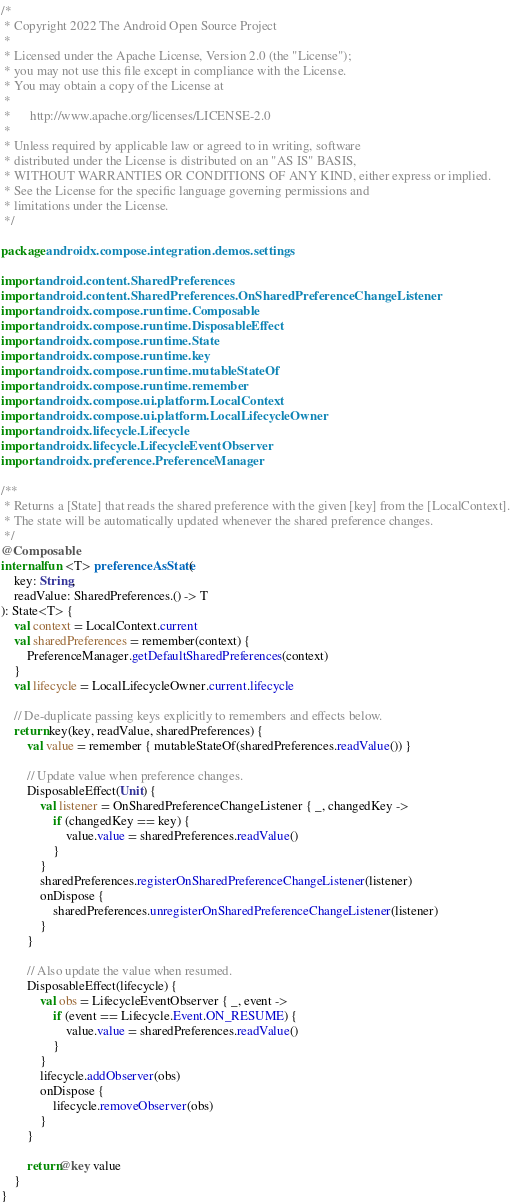<code> <loc_0><loc_0><loc_500><loc_500><_Kotlin_>/*
 * Copyright 2022 The Android Open Source Project
 *
 * Licensed under the Apache License, Version 2.0 (the "License");
 * you may not use this file except in compliance with the License.
 * You may obtain a copy of the License at
 *
 *      http://www.apache.org/licenses/LICENSE-2.0
 *
 * Unless required by applicable law or agreed to in writing, software
 * distributed under the License is distributed on an "AS IS" BASIS,
 * WITHOUT WARRANTIES OR CONDITIONS OF ANY KIND, either express or implied.
 * See the License for the specific language governing permissions and
 * limitations under the License.
 */

package androidx.compose.integration.demos.settings

import android.content.SharedPreferences
import android.content.SharedPreferences.OnSharedPreferenceChangeListener
import androidx.compose.runtime.Composable
import androidx.compose.runtime.DisposableEffect
import androidx.compose.runtime.State
import androidx.compose.runtime.key
import androidx.compose.runtime.mutableStateOf
import androidx.compose.runtime.remember
import androidx.compose.ui.platform.LocalContext
import androidx.compose.ui.platform.LocalLifecycleOwner
import androidx.lifecycle.Lifecycle
import androidx.lifecycle.LifecycleEventObserver
import androidx.preference.PreferenceManager

/**
 * Returns a [State] that reads the shared preference with the given [key] from the [LocalContext].
 * The state will be automatically updated whenever the shared preference changes.
 */
@Composable
internal fun <T> preferenceAsState(
    key: String,
    readValue: SharedPreferences.() -> T
): State<T> {
    val context = LocalContext.current
    val sharedPreferences = remember(context) {
        PreferenceManager.getDefaultSharedPreferences(context)
    }
    val lifecycle = LocalLifecycleOwner.current.lifecycle

    // De-duplicate passing keys explicitly to remembers and effects below.
    return key(key, readValue, sharedPreferences) {
        val value = remember { mutableStateOf(sharedPreferences.readValue()) }

        // Update value when preference changes.
        DisposableEffect(Unit) {
            val listener = OnSharedPreferenceChangeListener { _, changedKey ->
                if (changedKey == key) {
                    value.value = sharedPreferences.readValue()
                }
            }
            sharedPreferences.registerOnSharedPreferenceChangeListener(listener)
            onDispose {
                sharedPreferences.unregisterOnSharedPreferenceChangeListener(listener)
            }
        }

        // Also update the value when resumed.
        DisposableEffect(lifecycle) {
            val obs = LifecycleEventObserver { _, event ->
                if (event == Lifecycle.Event.ON_RESUME) {
                    value.value = sharedPreferences.readValue()
                }
            }
            lifecycle.addObserver(obs)
            onDispose {
                lifecycle.removeObserver(obs)
            }
        }

        return@key value
    }
}</code> 